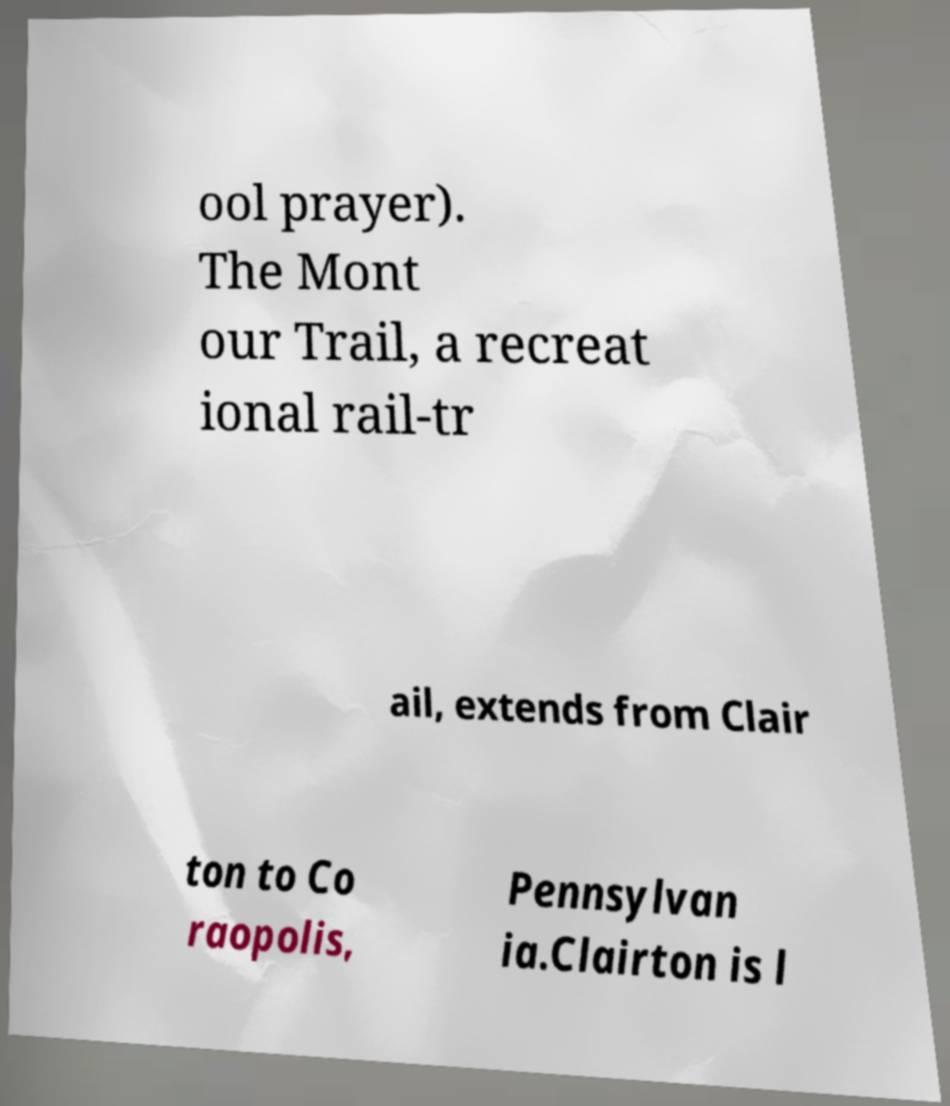Please identify and transcribe the text found in this image. ool prayer). The Mont our Trail, a recreat ional rail-tr ail, extends from Clair ton to Co raopolis, Pennsylvan ia.Clairton is l 